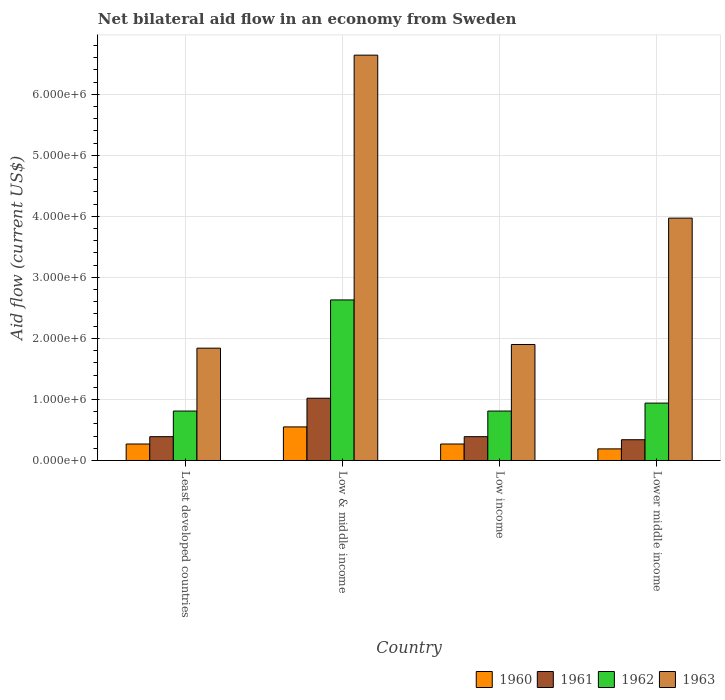How many different coloured bars are there?
Make the answer very short. 4. How many groups of bars are there?
Offer a terse response. 4. Are the number of bars on each tick of the X-axis equal?
Keep it short and to the point. Yes. How many bars are there on the 3rd tick from the right?
Your answer should be very brief. 4. What is the label of the 1st group of bars from the left?
Your response must be concise. Least developed countries. In how many cases, is the number of bars for a given country not equal to the number of legend labels?
Your answer should be very brief. 0. What is the net bilateral aid flow in 1960 in Low income?
Provide a short and direct response. 2.70e+05. Across all countries, what is the maximum net bilateral aid flow in 1963?
Give a very brief answer. 6.64e+06. Across all countries, what is the minimum net bilateral aid flow in 1961?
Give a very brief answer. 3.40e+05. In which country was the net bilateral aid flow in 1962 maximum?
Ensure brevity in your answer.  Low & middle income. In which country was the net bilateral aid flow in 1963 minimum?
Provide a short and direct response. Least developed countries. What is the total net bilateral aid flow in 1960 in the graph?
Provide a succinct answer. 1.28e+06. What is the difference between the net bilateral aid flow in 1961 in Low & middle income and that in Lower middle income?
Keep it short and to the point. 6.80e+05. What is the average net bilateral aid flow in 1961 per country?
Your answer should be very brief. 5.35e+05. What is the difference between the net bilateral aid flow of/in 1961 and net bilateral aid flow of/in 1960 in Least developed countries?
Make the answer very short. 1.20e+05. In how many countries, is the net bilateral aid flow in 1960 greater than 2600000 US$?
Your response must be concise. 0. What is the ratio of the net bilateral aid flow in 1960 in Least developed countries to that in Lower middle income?
Offer a terse response. 1.42. Is the net bilateral aid flow in 1963 in Least developed countries less than that in Lower middle income?
Offer a terse response. Yes. Is the difference between the net bilateral aid flow in 1961 in Least developed countries and Low & middle income greater than the difference between the net bilateral aid flow in 1960 in Least developed countries and Low & middle income?
Offer a very short reply. No. What is the difference between the highest and the lowest net bilateral aid flow in 1963?
Offer a terse response. 4.80e+06. Is it the case that in every country, the sum of the net bilateral aid flow in 1960 and net bilateral aid flow in 1962 is greater than the sum of net bilateral aid flow in 1961 and net bilateral aid flow in 1963?
Offer a terse response. Yes. What does the 3rd bar from the right in Least developed countries represents?
Your answer should be compact. 1961. Are all the bars in the graph horizontal?
Ensure brevity in your answer.  No. What is the difference between two consecutive major ticks on the Y-axis?
Provide a short and direct response. 1.00e+06. Are the values on the major ticks of Y-axis written in scientific E-notation?
Make the answer very short. Yes. Does the graph contain grids?
Provide a succinct answer. Yes. Where does the legend appear in the graph?
Keep it short and to the point. Bottom right. What is the title of the graph?
Offer a very short reply. Net bilateral aid flow in an economy from Sweden. Does "1989" appear as one of the legend labels in the graph?
Make the answer very short. No. What is the label or title of the X-axis?
Your response must be concise. Country. What is the label or title of the Y-axis?
Provide a succinct answer. Aid flow (current US$). What is the Aid flow (current US$) of 1960 in Least developed countries?
Your response must be concise. 2.70e+05. What is the Aid flow (current US$) of 1961 in Least developed countries?
Your response must be concise. 3.90e+05. What is the Aid flow (current US$) of 1962 in Least developed countries?
Offer a very short reply. 8.10e+05. What is the Aid flow (current US$) of 1963 in Least developed countries?
Your answer should be compact. 1.84e+06. What is the Aid flow (current US$) in 1961 in Low & middle income?
Ensure brevity in your answer.  1.02e+06. What is the Aid flow (current US$) of 1962 in Low & middle income?
Provide a succinct answer. 2.63e+06. What is the Aid flow (current US$) of 1963 in Low & middle income?
Your response must be concise. 6.64e+06. What is the Aid flow (current US$) in 1960 in Low income?
Make the answer very short. 2.70e+05. What is the Aid flow (current US$) in 1961 in Low income?
Give a very brief answer. 3.90e+05. What is the Aid flow (current US$) in 1962 in Low income?
Keep it short and to the point. 8.10e+05. What is the Aid flow (current US$) of 1963 in Low income?
Provide a short and direct response. 1.90e+06. What is the Aid flow (current US$) of 1960 in Lower middle income?
Offer a very short reply. 1.90e+05. What is the Aid flow (current US$) in 1961 in Lower middle income?
Offer a very short reply. 3.40e+05. What is the Aid flow (current US$) of 1962 in Lower middle income?
Provide a short and direct response. 9.40e+05. What is the Aid flow (current US$) in 1963 in Lower middle income?
Your answer should be compact. 3.97e+06. Across all countries, what is the maximum Aid flow (current US$) in 1961?
Offer a terse response. 1.02e+06. Across all countries, what is the maximum Aid flow (current US$) in 1962?
Ensure brevity in your answer.  2.63e+06. Across all countries, what is the maximum Aid flow (current US$) of 1963?
Your answer should be compact. 6.64e+06. Across all countries, what is the minimum Aid flow (current US$) of 1962?
Keep it short and to the point. 8.10e+05. Across all countries, what is the minimum Aid flow (current US$) in 1963?
Your answer should be very brief. 1.84e+06. What is the total Aid flow (current US$) of 1960 in the graph?
Your response must be concise. 1.28e+06. What is the total Aid flow (current US$) in 1961 in the graph?
Keep it short and to the point. 2.14e+06. What is the total Aid flow (current US$) in 1962 in the graph?
Provide a short and direct response. 5.19e+06. What is the total Aid flow (current US$) of 1963 in the graph?
Give a very brief answer. 1.44e+07. What is the difference between the Aid flow (current US$) in 1960 in Least developed countries and that in Low & middle income?
Your answer should be very brief. -2.80e+05. What is the difference between the Aid flow (current US$) of 1961 in Least developed countries and that in Low & middle income?
Your response must be concise. -6.30e+05. What is the difference between the Aid flow (current US$) in 1962 in Least developed countries and that in Low & middle income?
Your response must be concise. -1.82e+06. What is the difference between the Aid flow (current US$) of 1963 in Least developed countries and that in Low & middle income?
Provide a short and direct response. -4.80e+06. What is the difference between the Aid flow (current US$) in 1962 in Least developed countries and that in Low income?
Give a very brief answer. 0. What is the difference between the Aid flow (current US$) of 1960 in Least developed countries and that in Lower middle income?
Your response must be concise. 8.00e+04. What is the difference between the Aid flow (current US$) of 1963 in Least developed countries and that in Lower middle income?
Make the answer very short. -2.13e+06. What is the difference between the Aid flow (current US$) of 1961 in Low & middle income and that in Low income?
Your answer should be compact. 6.30e+05. What is the difference between the Aid flow (current US$) in 1962 in Low & middle income and that in Low income?
Your response must be concise. 1.82e+06. What is the difference between the Aid flow (current US$) of 1963 in Low & middle income and that in Low income?
Make the answer very short. 4.74e+06. What is the difference between the Aid flow (current US$) of 1960 in Low & middle income and that in Lower middle income?
Make the answer very short. 3.60e+05. What is the difference between the Aid flow (current US$) in 1961 in Low & middle income and that in Lower middle income?
Provide a short and direct response. 6.80e+05. What is the difference between the Aid flow (current US$) in 1962 in Low & middle income and that in Lower middle income?
Offer a terse response. 1.69e+06. What is the difference between the Aid flow (current US$) of 1963 in Low & middle income and that in Lower middle income?
Provide a short and direct response. 2.67e+06. What is the difference between the Aid flow (current US$) in 1960 in Low income and that in Lower middle income?
Your answer should be very brief. 8.00e+04. What is the difference between the Aid flow (current US$) in 1962 in Low income and that in Lower middle income?
Ensure brevity in your answer.  -1.30e+05. What is the difference between the Aid flow (current US$) of 1963 in Low income and that in Lower middle income?
Provide a succinct answer. -2.07e+06. What is the difference between the Aid flow (current US$) in 1960 in Least developed countries and the Aid flow (current US$) in 1961 in Low & middle income?
Ensure brevity in your answer.  -7.50e+05. What is the difference between the Aid flow (current US$) in 1960 in Least developed countries and the Aid flow (current US$) in 1962 in Low & middle income?
Offer a terse response. -2.36e+06. What is the difference between the Aid flow (current US$) in 1960 in Least developed countries and the Aid flow (current US$) in 1963 in Low & middle income?
Your answer should be very brief. -6.37e+06. What is the difference between the Aid flow (current US$) in 1961 in Least developed countries and the Aid flow (current US$) in 1962 in Low & middle income?
Make the answer very short. -2.24e+06. What is the difference between the Aid flow (current US$) in 1961 in Least developed countries and the Aid flow (current US$) in 1963 in Low & middle income?
Your answer should be compact. -6.25e+06. What is the difference between the Aid flow (current US$) of 1962 in Least developed countries and the Aid flow (current US$) of 1963 in Low & middle income?
Your answer should be very brief. -5.83e+06. What is the difference between the Aid flow (current US$) of 1960 in Least developed countries and the Aid flow (current US$) of 1962 in Low income?
Provide a succinct answer. -5.40e+05. What is the difference between the Aid flow (current US$) in 1960 in Least developed countries and the Aid flow (current US$) in 1963 in Low income?
Ensure brevity in your answer.  -1.63e+06. What is the difference between the Aid flow (current US$) in 1961 in Least developed countries and the Aid flow (current US$) in 1962 in Low income?
Give a very brief answer. -4.20e+05. What is the difference between the Aid flow (current US$) in 1961 in Least developed countries and the Aid flow (current US$) in 1963 in Low income?
Your answer should be very brief. -1.51e+06. What is the difference between the Aid flow (current US$) of 1962 in Least developed countries and the Aid flow (current US$) of 1963 in Low income?
Make the answer very short. -1.09e+06. What is the difference between the Aid flow (current US$) of 1960 in Least developed countries and the Aid flow (current US$) of 1961 in Lower middle income?
Make the answer very short. -7.00e+04. What is the difference between the Aid flow (current US$) in 1960 in Least developed countries and the Aid flow (current US$) in 1962 in Lower middle income?
Give a very brief answer. -6.70e+05. What is the difference between the Aid flow (current US$) in 1960 in Least developed countries and the Aid flow (current US$) in 1963 in Lower middle income?
Ensure brevity in your answer.  -3.70e+06. What is the difference between the Aid flow (current US$) of 1961 in Least developed countries and the Aid flow (current US$) of 1962 in Lower middle income?
Your answer should be very brief. -5.50e+05. What is the difference between the Aid flow (current US$) in 1961 in Least developed countries and the Aid flow (current US$) in 1963 in Lower middle income?
Give a very brief answer. -3.58e+06. What is the difference between the Aid flow (current US$) in 1962 in Least developed countries and the Aid flow (current US$) in 1963 in Lower middle income?
Provide a succinct answer. -3.16e+06. What is the difference between the Aid flow (current US$) of 1960 in Low & middle income and the Aid flow (current US$) of 1963 in Low income?
Your response must be concise. -1.35e+06. What is the difference between the Aid flow (current US$) in 1961 in Low & middle income and the Aid flow (current US$) in 1963 in Low income?
Provide a short and direct response. -8.80e+05. What is the difference between the Aid flow (current US$) in 1962 in Low & middle income and the Aid flow (current US$) in 1963 in Low income?
Your answer should be compact. 7.30e+05. What is the difference between the Aid flow (current US$) in 1960 in Low & middle income and the Aid flow (current US$) in 1962 in Lower middle income?
Offer a terse response. -3.90e+05. What is the difference between the Aid flow (current US$) of 1960 in Low & middle income and the Aid flow (current US$) of 1963 in Lower middle income?
Provide a succinct answer. -3.42e+06. What is the difference between the Aid flow (current US$) of 1961 in Low & middle income and the Aid flow (current US$) of 1962 in Lower middle income?
Provide a succinct answer. 8.00e+04. What is the difference between the Aid flow (current US$) in 1961 in Low & middle income and the Aid flow (current US$) in 1963 in Lower middle income?
Your answer should be compact. -2.95e+06. What is the difference between the Aid flow (current US$) of 1962 in Low & middle income and the Aid flow (current US$) of 1963 in Lower middle income?
Offer a very short reply. -1.34e+06. What is the difference between the Aid flow (current US$) of 1960 in Low income and the Aid flow (current US$) of 1961 in Lower middle income?
Ensure brevity in your answer.  -7.00e+04. What is the difference between the Aid flow (current US$) in 1960 in Low income and the Aid flow (current US$) in 1962 in Lower middle income?
Your answer should be compact. -6.70e+05. What is the difference between the Aid flow (current US$) in 1960 in Low income and the Aid flow (current US$) in 1963 in Lower middle income?
Provide a succinct answer. -3.70e+06. What is the difference between the Aid flow (current US$) in 1961 in Low income and the Aid flow (current US$) in 1962 in Lower middle income?
Your response must be concise. -5.50e+05. What is the difference between the Aid flow (current US$) in 1961 in Low income and the Aid flow (current US$) in 1963 in Lower middle income?
Your response must be concise. -3.58e+06. What is the difference between the Aid flow (current US$) in 1962 in Low income and the Aid flow (current US$) in 1963 in Lower middle income?
Your answer should be very brief. -3.16e+06. What is the average Aid flow (current US$) in 1960 per country?
Keep it short and to the point. 3.20e+05. What is the average Aid flow (current US$) in 1961 per country?
Keep it short and to the point. 5.35e+05. What is the average Aid flow (current US$) of 1962 per country?
Give a very brief answer. 1.30e+06. What is the average Aid flow (current US$) in 1963 per country?
Give a very brief answer. 3.59e+06. What is the difference between the Aid flow (current US$) of 1960 and Aid flow (current US$) of 1962 in Least developed countries?
Your answer should be compact. -5.40e+05. What is the difference between the Aid flow (current US$) in 1960 and Aid flow (current US$) in 1963 in Least developed countries?
Ensure brevity in your answer.  -1.57e+06. What is the difference between the Aid flow (current US$) in 1961 and Aid flow (current US$) in 1962 in Least developed countries?
Offer a very short reply. -4.20e+05. What is the difference between the Aid flow (current US$) in 1961 and Aid flow (current US$) in 1963 in Least developed countries?
Your answer should be very brief. -1.45e+06. What is the difference between the Aid flow (current US$) in 1962 and Aid flow (current US$) in 1963 in Least developed countries?
Your answer should be compact. -1.03e+06. What is the difference between the Aid flow (current US$) of 1960 and Aid flow (current US$) of 1961 in Low & middle income?
Offer a very short reply. -4.70e+05. What is the difference between the Aid flow (current US$) of 1960 and Aid flow (current US$) of 1962 in Low & middle income?
Your answer should be compact. -2.08e+06. What is the difference between the Aid flow (current US$) in 1960 and Aid flow (current US$) in 1963 in Low & middle income?
Make the answer very short. -6.09e+06. What is the difference between the Aid flow (current US$) in 1961 and Aid flow (current US$) in 1962 in Low & middle income?
Give a very brief answer. -1.61e+06. What is the difference between the Aid flow (current US$) of 1961 and Aid flow (current US$) of 1963 in Low & middle income?
Your answer should be compact. -5.62e+06. What is the difference between the Aid flow (current US$) in 1962 and Aid flow (current US$) in 1963 in Low & middle income?
Offer a very short reply. -4.01e+06. What is the difference between the Aid flow (current US$) of 1960 and Aid flow (current US$) of 1962 in Low income?
Your answer should be compact. -5.40e+05. What is the difference between the Aid flow (current US$) in 1960 and Aid flow (current US$) in 1963 in Low income?
Your response must be concise. -1.63e+06. What is the difference between the Aid flow (current US$) in 1961 and Aid flow (current US$) in 1962 in Low income?
Offer a very short reply. -4.20e+05. What is the difference between the Aid flow (current US$) in 1961 and Aid flow (current US$) in 1963 in Low income?
Ensure brevity in your answer.  -1.51e+06. What is the difference between the Aid flow (current US$) in 1962 and Aid flow (current US$) in 1963 in Low income?
Your answer should be compact. -1.09e+06. What is the difference between the Aid flow (current US$) in 1960 and Aid flow (current US$) in 1962 in Lower middle income?
Provide a succinct answer. -7.50e+05. What is the difference between the Aid flow (current US$) in 1960 and Aid flow (current US$) in 1963 in Lower middle income?
Your response must be concise. -3.78e+06. What is the difference between the Aid flow (current US$) of 1961 and Aid flow (current US$) of 1962 in Lower middle income?
Offer a very short reply. -6.00e+05. What is the difference between the Aid flow (current US$) in 1961 and Aid flow (current US$) in 1963 in Lower middle income?
Offer a terse response. -3.63e+06. What is the difference between the Aid flow (current US$) of 1962 and Aid flow (current US$) of 1963 in Lower middle income?
Give a very brief answer. -3.03e+06. What is the ratio of the Aid flow (current US$) in 1960 in Least developed countries to that in Low & middle income?
Provide a short and direct response. 0.49. What is the ratio of the Aid flow (current US$) of 1961 in Least developed countries to that in Low & middle income?
Offer a terse response. 0.38. What is the ratio of the Aid flow (current US$) in 1962 in Least developed countries to that in Low & middle income?
Your answer should be very brief. 0.31. What is the ratio of the Aid flow (current US$) of 1963 in Least developed countries to that in Low & middle income?
Provide a short and direct response. 0.28. What is the ratio of the Aid flow (current US$) of 1960 in Least developed countries to that in Low income?
Ensure brevity in your answer.  1. What is the ratio of the Aid flow (current US$) in 1963 in Least developed countries to that in Low income?
Ensure brevity in your answer.  0.97. What is the ratio of the Aid flow (current US$) of 1960 in Least developed countries to that in Lower middle income?
Offer a terse response. 1.42. What is the ratio of the Aid flow (current US$) of 1961 in Least developed countries to that in Lower middle income?
Offer a very short reply. 1.15. What is the ratio of the Aid flow (current US$) of 1962 in Least developed countries to that in Lower middle income?
Your response must be concise. 0.86. What is the ratio of the Aid flow (current US$) in 1963 in Least developed countries to that in Lower middle income?
Offer a very short reply. 0.46. What is the ratio of the Aid flow (current US$) of 1960 in Low & middle income to that in Low income?
Provide a short and direct response. 2.04. What is the ratio of the Aid flow (current US$) of 1961 in Low & middle income to that in Low income?
Ensure brevity in your answer.  2.62. What is the ratio of the Aid flow (current US$) of 1962 in Low & middle income to that in Low income?
Provide a short and direct response. 3.25. What is the ratio of the Aid flow (current US$) in 1963 in Low & middle income to that in Low income?
Offer a terse response. 3.49. What is the ratio of the Aid flow (current US$) in 1960 in Low & middle income to that in Lower middle income?
Your response must be concise. 2.89. What is the ratio of the Aid flow (current US$) of 1962 in Low & middle income to that in Lower middle income?
Offer a terse response. 2.8. What is the ratio of the Aid flow (current US$) of 1963 in Low & middle income to that in Lower middle income?
Offer a very short reply. 1.67. What is the ratio of the Aid flow (current US$) in 1960 in Low income to that in Lower middle income?
Keep it short and to the point. 1.42. What is the ratio of the Aid flow (current US$) of 1961 in Low income to that in Lower middle income?
Offer a very short reply. 1.15. What is the ratio of the Aid flow (current US$) in 1962 in Low income to that in Lower middle income?
Make the answer very short. 0.86. What is the ratio of the Aid flow (current US$) in 1963 in Low income to that in Lower middle income?
Your answer should be compact. 0.48. What is the difference between the highest and the second highest Aid flow (current US$) of 1961?
Keep it short and to the point. 6.30e+05. What is the difference between the highest and the second highest Aid flow (current US$) in 1962?
Your response must be concise. 1.69e+06. What is the difference between the highest and the second highest Aid flow (current US$) in 1963?
Your answer should be very brief. 2.67e+06. What is the difference between the highest and the lowest Aid flow (current US$) in 1960?
Provide a succinct answer. 3.60e+05. What is the difference between the highest and the lowest Aid flow (current US$) of 1961?
Provide a succinct answer. 6.80e+05. What is the difference between the highest and the lowest Aid flow (current US$) of 1962?
Give a very brief answer. 1.82e+06. What is the difference between the highest and the lowest Aid flow (current US$) in 1963?
Your response must be concise. 4.80e+06. 